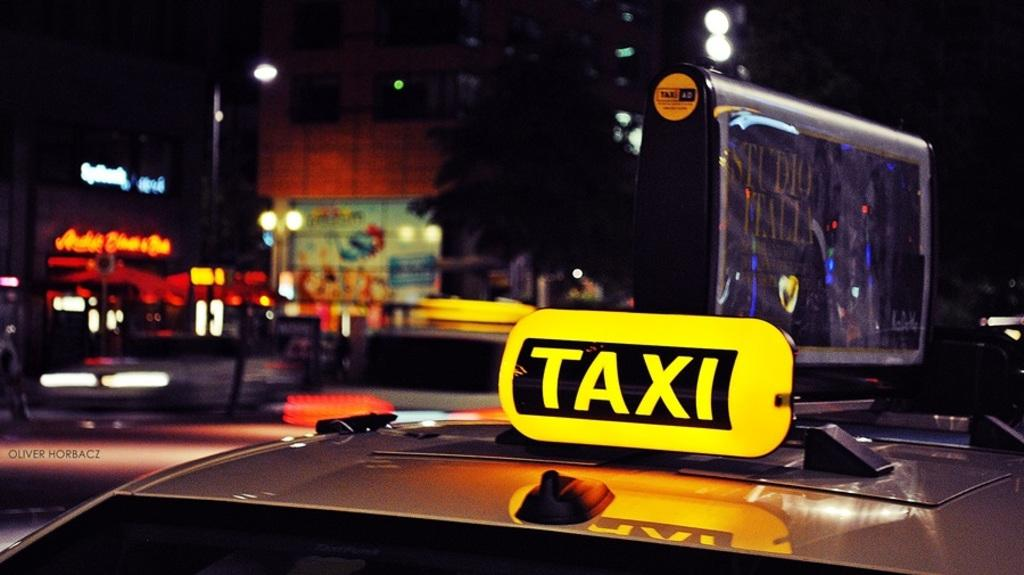<image>
Render a clear and concise summary of the photo. A taxi in traffic on a dark city street. 